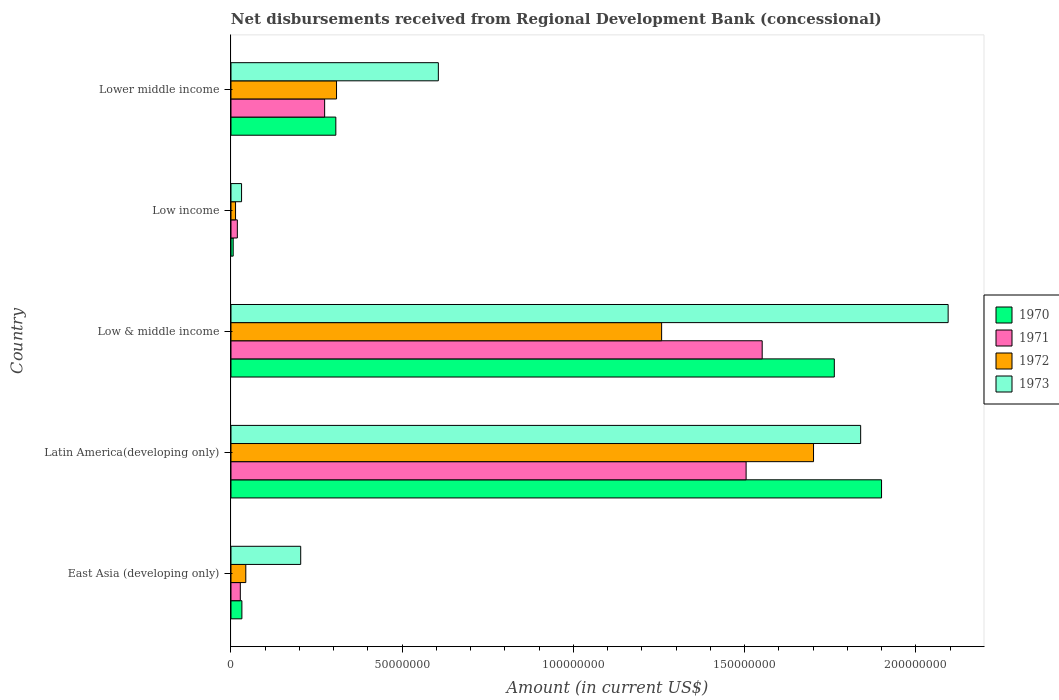How many different coloured bars are there?
Your answer should be compact. 4. How many groups of bars are there?
Offer a terse response. 5. Are the number of bars on each tick of the Y-axis equal?
Ensure brevity in your answer.  Yes. How many bars are there on the 3rd tick from the top?
Offer a terse response. 4. What is the label of the 1st group of bars from the top?
Keep it short and to the point. Lower middle income. In how many cases, is the number of bars for a given country not equal to the number of legend labels?
Your response must be concise. 0. What is the amount of disbursements received from Regional Development Bank in 1970 in Lower middle income?
Provide a short and direct response. 3.06e+07. Across all countries, what is the maximum amount of disbursements received from Regional Development Bank in 1970?
Give a very brief answer. 1.90e+08. Across all countries, what is the minimum amount of disbursements received from Regional Development Bank in 1973?
Keep it short and to the point. 3.09e+06. In which country was the amount of disbursements received from Regional Development Bank in 1971 maximum?
Provide a succinct answer. Low & middle income. In which country was the amount of disbursements received from Regional Development Bank in 1971 minimum?
Offer a terse response. Low income. What is the total amount of disbursements received from Regional Development Bank in 1972 in the graph?
Give a very brief answer. 3.32e+08. What is the difference between the amount of disbursements received from Regional Development Bank in 1971 in Latin America(developing only) and that in Low & middle income?
Provide a short and direct response. -4.69e+06. What is the difference between the amount of disbursements received from Regional Development Bank in 1972 in Latin America(developing only) and the amount of disbursements received from Regional Development Bank in 1973 in Lower middle income?
Provide a short and direct response. 1.10e+08. What is the average amount of disbursements received from Regional Development Bank in 1973 per country?
Your answer should be compact. 9.55e+07. What is the difference between the amount of disbursements received from Regional Development Bank in 1971 and amount of disbursements received from Regional Development Bank in 1973 in Low income?
Make the answer very short. -1.23e+06. What is the ratio of the amount of disbursements received from Regional Development Bank in 1971 in East Asia (developing only) to that in Low & middle income?
Your answer should be very brief. 0.02. What is the difference between the highest and the second highest amount of disbursements received from Regional Development Bank in 1972?
Your response must be concise. 4.44e+07. What is the difference between the highest and the lowest amount of disbursements received from Regional Development Bank in 1970?
Your answer should be compact. 1.89e+08. Is the sum of the amount of disbursements received from Regional Development Bank in 1973 in Latin America(developing only) and Lower middle income greater than the maximum amount of disbursements received from Regional Development Bank in 1970 across all countries?
Offer a terse response. Yes. Is it the case that in every country, the sum of the amount of disbursements received from Regional Development Bank in 1970 and amount of disbursements received from Regional Development Bank in 1971 is greater than the sum of amount of disbursements received from Regional Development Bank in 1973 and amount of disbursements received from Regional Development Bank in 1972?
Keep it short and to the point. No. What does the 1st bar from the top in Low income represents?
Give a very brief answer. 1973. What does the 4th bar from the bottom in Latin America(developing only) represents?
Provide a short and direct response. 1973. Is it the case that in every country, the sum of the amount of disbursements received from Regional Development Bank in 1973 and amount of disbursements received from Regional Development Bank in 1972 is greater than the amount of disbursements received from Regional Development Bank in 1970?
Your answer should be compact. Yes. Are all the bars in the graph horizontal?
Your answer should be very brief. Yes. How many countries are there in the graph?
Your response must be concise. 5. Where does the legend appear in the graph?
Provide a succinct answer. Center right. How are the legend labels stacked?
Offer a very short reply. Vertical. What is the title of the graph?
Offer a terse response. Net disbursements received from Regional Development Bank (concessional). Does "1994" appear as one of the legend labels in the graph?
Offer a very short reply. No. What is the Amount (in current US$) in 1970 in East Asia (developing only)?
Give a very brief answer. 3.19e+06. What is the Amount (in current US$) of 1971 in East Asia (developing only)?
Your answer should be compact. 2.73e+06. What is the Amount (in current US$) in 1972 in East Asia (developing only)?
Your answer should be very brief. 4.33e+06. What is the Amount (in current US$) of 1973 in East Asia (developing only)?
Keep it short and to the point. 2.04e+07. What is the Amount (in current US$) in 1970 in Latin America(developing only)?
Offer a very short reply. 1.90e+08. What is the Amount (in current US$) of 1971 in Latin America(developing only)?
Your answer should be compact. 1.50e+08. What is the Amount (in current US$) in 1972 in Latin America(developing only)?
Provide a succinct answer. 1.70e+08. What is the Amount (in current US$) in 1973 in Latin America(developing only)?
Offer a very short reply. 1.84e+08. What is the Amount (in current US$) in 1970 in Low & middle income?
Provide a succinct answer. 1.76e+08. What is the Amount (in current US$) of 1971 in Low & middle income?
Offer a very short reply. 1.55e+08. What is the Amount (in current US$) in 1972 in Low & middle income?
Give a very brief answer. 1.26e+08. What is the Amount (in current US$) of 1973 in Low & middle income?
Provide a short and direct response. 2.09e+08. What is the Amount (in current US$) of 1970 in Low income?
Provide a short and direct response. 6.47e+05. What is the Amount (in current US$) in 1971 in Low income?
Offer a terse response. 1.86e+06. What is the Amount (in current US$) of 1972 in Low income?
Make the answer very short. 1.33e+06. What is the Amount (in current US$) in 1973 in Low income?
Offer a very short reply. 3.09e+06. What is the Amount (in current US$) of 1970 in Lower middle income?
Ensure brevity in your answer.  3.06e+07. What is the Amount (in current US$) of 1971 in Lower middle income?
Keep it short and to the point. 2.74e+07. What is the Amount (in current US$) of 1972 in Lower middle income?
Make the answer very short. 3.08e+07. What is the Amount (in current US$) of 1973 in Lower middle income?
Keep it short and to the point. 6.06e+07. Across all countries, what is the maximum Amount (in current US$) in 1970?
Offer a very short reply. 1.90e+08. Across all countries, what is the maximum Amount (in current US$) of 1971?
Provide a succinct answer. 1.55e+08. Across all countries, what is the maximum Amount (in current US$) in 1972?
Make the answer very short. 1.70e+08. Across all countries, what is the maximum Amount (in current US$) of 1973?
Offer a very short reply. 2.09e+08. Across all countries, what is the minimum Amount (in current US$) in 1970?
Offer a very short reply. 6.47e+05. Across all countries, what is the minimum Amount (in current US$) of 1971?
Your answer should be very brief. 1.86e+06. Across all countries, what is the minimum Amount (in current US$) of 1972?
Offer a very short reply. 1.33e+06. Across all countries, what is the minimum Amount (in current US$) in 1973?
Give a very brief answer. 3.09e+06. What is the total Amount (in current US$) of 1970 in the graph?
Your answer should be compact. 4.01e+08. What is the total Amount (in current US$) in 1971 in the graph?
Provide a succinct answer. 3.38e+08. What is the total Amount (in current US$) of 1972 in the graph?
Keep it short and to the point. 3.32e+08. What is the total Amount (in current US$) of 1973 in the graph?
Offer a very short reply. 4.77e+08. What is the difference between the Amount (in current US$) in 1970 in East Asia (developing only) and that in Latin America(developing only)?
Provide a succinct answer. -1.87e+08. What is the difference between the Amount (in current US$) of 1971 in East Asia (developing only) and that in Latin America(developing only)?
Your response must be concise. -1.48e+08. What is the difference between the Amount (in current US$) in 1972 in East Asia (developing only) and that in Latin America(developing only)?
Your response must be concise. -1.66e+08. What is the difference between the Amount (in current US$) of 1973 in East Asia (developing only) and that in Latin America(developing only)?
Give a very brief answer. -1.64e+08. What is the difference between the Amount (in current US$) of 1970 in East Asia (developing only) and that in Low & middle income?
Give a very brief answer. -1.73e+08. What is the difference between the Amount (in current US$) in 1971 in East Asia (developing only) and that in Low & middle income?
Offer a very short reply. -1.52e+08. What is the difference between the Amount (in current US$) of 1972 in East Asia (developing only) and that in Low & middle income?
Make the answer very short. -1.21e+08. What is the difference between the Amount (in current US$) in 1973 in East Asia (developing only) and that in Low & middle income?
Provide a succinct answer. -1.89e+08. What is the difference between the Amount (in current US$) in 1970 in East Asia (developing only) and that in Low income?
Offer a terse response. 2.54e+06. What is the difference between the Amount (in current US$) of 1971 in East Asia (developing only) and that in Low income?
Your answer should be very brief. 8.69e+05. What is the difference between the Amount (in current US$) in 1972 in East Asia (developing only) and that in Low income?
Keep it short and to the point. 2.99e+06. What is the difference between the Amount (in current US$) in 1973 in East Asia (developing only) and that in Low income?
Offer a terse response. 1.73e+07. What is the difference between the Amount (in current US$) in 1970 in East Asia (developing only) and that in Lower middle income?
Offer a terse response. -2.74e+07. What is the difference between the Amount (in current US$) of 1971 in East Asia (developing only) and that in Lower middle income?
Ensure brevity in your answer.  -2.46e+07. What is the difference between the Amount (in current US$) in 1972 in East Asia (developing only) and that in Lower middle income?
Your response must be concise. -2.65e+07. What is the difference between the Amount (in current US$) of 1973 in East Asia (developing only) and that in Lower middle income?
Ensure brevity in your answer.  -4.02e+07. What is the difference between the Amount (in current US$) in 1970 in Latin America(developing only) and that in Low & middle income?
Offer a very short reply. 1.38e+07. What is the difference between the Amount (in current US$) in 1971 in Latin America(developing only) and that in Low & middle income?
Keep it short and to the point. -4.69e+06. What is the difference between the Amount (in current US$) in 1972 in Latin America(developing only) and that in Low & middle income?
Your answer should be very brief. 4.44e+07. What is the difference between the Amount (in current US$) in 1973 in Latin America(developing only) and that in Low & middle income?
Keep it short and to the point. -2.55e+07. What is the difference between the Amount (in current US$) of 1970 in Latin America(developing only) and that in Low income?
Ensure brevity in your answer.  1.89e+08. What is the difference between the Amount (in current US$) in 1971 in Latin America(developing only) and that in Low income?
Make the answer very short. 1.49e+08. What is the difference between the Amount (in current US$) in 1972 in Latin America(developing only) and that in Low income?
Your response must be concise. 1.69e+08. What is the difference between the Amount (in current US$) in 1973 in Latin America(developing only) and that in Low income?
Your answer should be compact. 1.81e+08. What is the difference between the Amount (in current US$) of 1970 in Latin America(developing only) and that in Lower middle income?
Your response must be concise. 1.59e+08. What is the difference between the Amount (in current US$) in 1971 in Latin America(developing only) and that in Lower middle income?
Ensure brevity in your answer.  1.23e+08. What is the difference between the Amount (in current US$) of 1972 in Latin America(developing only) and that in Lower middle income?
Keep it short and to the point. 1.39e+08. What is the difference between the Amount (in current US$) of 1973 in Latin America(developing only) and that in Lower middle income?
Your answer should be compact. 1.23e+08. What is the difference between the Amount (in current US$) in 1970 in Low & middle income and that in Low income?
Give a very brief answer. 1.76e+08. What is the difference between the Amount (in current US$) in 1971 in Low & middle income and that in Low income?
Offer a terse response. 1.53e+08. What is the difference between the Amount (in current US$) of 1972 in Low & middle income and that in Low income?
Ensure brevity in your answer.  1.24e+08. What is the difference between the Amount (in current US$) of 1973 in Low & middle income and that in Low income?
Offer a terse response. 2.06e+08. What is the difference between the Amount (in current US$) of 1970 in Low & middle income and that in Lower middle income?
Give a very brief answer. 1.46e+08. What is the difference between the Amount (in current US$) in 1971 in Low & middle income and that in Lower middle income?
Give a very brief answer. 1.28e+08. What is the difference between the Amount (in current US$) of 1972 in Low & middle income and that in Lower middle income?
Provide a succinct answer. 9.49e+07. What is the difference between the Amount (in current US$) of 1973 in Low & middle income and that in Lower middle income?
Offer a very short reply. 1.49e+08. What is the difference between the Amount (in current US$) of 1970 in Low income and that in Lower middle income?
Provide a short and direct response. -3.00e+07. What is the difference between the Amount (in current US$) of 1971 in Low income and that in Lower middle income?
Give a very brief answer. -2.55e+07. What is the difference between the Amount (in current US$) in 1972 in Low income and that in Lower middle income?
Keep it short and to the point. -2.95e+07. What is the difference between the Amount (in current US$) in 1973 in Low income and that in Lower middle income?
Give a very brief answer. -5.75e+07. What is the difference between the Amount (in current US$) in 1970 in East Asia (developing only) and the Amount (in current US$) in 1971 in Latin America(developing only)?
Ensure brevity in your answer.  -1.47e+08. What is the difference between the Amount (in current US$) in 1970 in East Asia (developing only) and the Amount (in current US$) in 1972 in Latin America(developing only)?
Your response must be concise. -1.67e+08. What is the difference between the Amount (in current US$) of 1970 in East Asia (developing only) and the Amount (in current US$) of 1973 in Latin America(developing only)?
Make the answer very short. -1.81e+08. What is the difference between the Amount (in current US$) in 1971 in East Asia (developing only) and the Amount (in current US$) in 1972 in Latin America(developing only)?
Offer a terse response. -1.67e+08. What is the difference between the Amount (in current US$) of 1971 in East Asia (developing only) and the Amount (in current US$) of 1973 in Latin America(developing only)?
Keep it short and to the point. -1.81e+08. What is the difference between the Amount (in current US$) of 1972 in East Asia (developing only) and the Amount (in current US$) of 1973 in Latin America(developing only)?
Make the answer very short. -1.80e+08. What is the difference between the Amount (in current US$) of 1970 in East Asia (developing only) and the Amount (in current US$) of 1971 in Low & middle income?
Ensure brevity in your answer.  -1.52e+08. What is the difference between the Amount (in current US$) in 1970 in East Asia (developing only) and the Amount (in current US$) in 1972 in Low & middle income?
Offer a very short reply. -1.23e+08. What is the difference between the Amount (in current US$) in 1970 in East Asia (developing only) and the Amount (in current US$) in 1973 in Low & middle income?
Keep it short and to the point. -2.06e+08. What is the difference between the Amount (in current US$) in 1971 in East Asia (developing only) and the Amount (in current US$) in 1972 in Low & middle income?
Keep it short and to the point. -1.23e+08. What is the difference between the Amount (in current US$) in 1971 in East Asia (developing only) and the Amount (in current US$) in 1973 in Low & middle income?
Provide a succinct answer. -2.07e+08. What is the difference between the Amount (in current US$) of 1972 in East Asia (developing only) and the Amount (in current US$) of 1973 in Low & middle income?
Your response must be concise. -2.05e+08. What is the difference between the Amount (in current US$) of 1970 in East Asia (developing only) and the Amount (in current US$) of 1971 in Low income?
Make the answer very short. 1.33e+06. What is the difference between the Amount (in current US$) of 1970 in East Asia (developing only) and the Amount (in current US$) of 1972 in Low income?
Provide a short and direct response. 1.86e+06. What is the difference between the Amount (in current US$) in 1970 in East Asia (developing only) and the Amount (in current US$) in 1973 in Low income?
Provide a succinct answer. 9.80e+04. What is the difference between the Amount (in current US$) in 1971 in East Asia (developing only) and the Amount (in current US$) in 1972 in Low income?
Make the answer very short. 1.40e+06. What is the difference between the Amount (in current US$) of 1971 in East Asia (developing only) and the Amount (in current US$) of 1973 in Low income?
Provide a short and direct response. -3.63e+05. What is the difference between the Amount (in current US$) of 1972 in East Asia (developing only) and the Amount (in current US$) of 1973 in Low income?
Make the answer very short. 1.24e+06. What is the difference between the Amount (in current US$) in 1970 in East Asia (developing only) and the Amount (in current US$) in 1971 in Lower middle income?
Your response must be concise. -2.42e+07. What is the difference between the Amount (in current US$) in 1970 in East Asia (developing only) and the Amount (in current US$) in 1972 in Lower middle income?
Provide a succinct answer. -2.76e+07. What is the difference between the Amount (in current US$) of 1970 in East Asia (developing only) and the Amount (in current US$) of 1973 in Lower middle income?
Your answer should be compact. -5.74e+07. What is the difference between the Amount (in current US$) in 1971 in East Asia (developing only) and the Amount (in current US$) in 1972 in Lower middle income?
Keep it short and to the point. -2.81e+07. What is the difference between the Amount (in current US$) in 1971 in East Asia (developing only) and the Amount (in current US$) in 1973 in Lower middle income?
Provide a short and direct response. -5.78e+07. What is the difference between the Amount (in current US$) of 1972 in East Asia (developing only) and the Amount (in current US$) of 1973 in Lower middle income?
Offer a terse response. -5.62e+07. What is the difference between the Amount (in current US$) in 1970 in Latin America(developing only) and the Amount (in current US$) in 1971 in Low & middle income?
Offer a terse response. 3.49e+07. What is the difference between the Amount (in current US$) of 1970 in Latin America(developing only) and the Amount (in current US$) of 1972 in Low & middle income?
Ensure brevity in your answer.  6.42e+07. What is the difference between the Amount (in current US$) in 1970 in Latin America(developing only) and the Amount (in current US$) in 1973 in Low & middle income?
Ensure brevity in your answer.  -1.94e+07. What is the difference between the Amount (in current US$) in 1971 in Latin America(developing only) and the Amount (in current US$) in 1972 in Low & middle income?
Provide a succinct answer. 2.47e+07. What is the difference between the Amount (in current US$) of 1971 in Latin America(developing only) and the Amount (in current US$) of 1973 in Low & middle income?
Offer a very short reply. -5.90e+07. What is the difference between the Amount (in current US$) of 1972 in Latin America(developing only) and the Amount (in current US$) of 1973 in Low & middle income?
Provide a succinct answer. -3.93e+07. What is the difference between the Amount (in current US$) in 1970 in Latin America(developing only) and the Amount (in current US$) in 1971 in Low income?
Provide a short and direct response. 1.88e+08. What is the difference between the Amount (in current US$) of 1970 in Latin America(developing only) and the Amount (in current US$) of 1972 in Low income?
Your answer should be very brief. 1.89e+08. What is the difference between the Amount (in current US$) of 1970 in Latin America(developing only) and the Amount (in current US$) of 1973 in Low income?
Make the answer very short. 1.87e+08. What is the difference between the Amount (in current US$) of 1971 in Latin America(developing only) and the Amount (in current US$) of 1972 in Low income?
Offer a terse response. 1.49e+08. What is the difference between the Amount (in current US$) in 1971 in Latin America(developing only) and the Amount (in current US$) in 1973 in Low income?
Ensure brevity in your answer.  1.47e+08. What is the difference between the Amount (in current US$) in 1972 in Latin America(developing only) and the Amount (in current US$) in 1973 in Low income?
Your answer should be very brief. 1.67e+08. What is the difference between the Amount (in current US$) in 1970 in Latin America(developing only) and the Amount (in current US$) in 1971 in Lower middle income?
Provide a succinct answer. 1.63e+08. What is the difference between the Amount (in current US$) in 1970 in Latin America(developing only) and the Amount (in current US$) in 1972 in Lower middle income?
Keep it short and to the point. 1.59e+08. What is the difference between the Amount (in current US$) in 1970 in Latin America(developing only) and the Amount (in current US$) in 1973 in Lower middle income?
Provide a short and direct response. 1.29e+08. What is the difference between the Amount (in current US$) of 1971 in Latin America(developing only) and the Amount (in current US$) of 1972 in Lower middle income?
Make the answer very short. 1.20e+08. What is the difference between the Amount (in current US$) of 1971 in Latin America(developing only) and the Amount (in current US$) of 1973 in Lower middle income?
Offer a terse response. 8.99e+07. What is the difference between the Amount (in current US$) in 1972 in Latin America(developing only) and the Amount (in current US$) in 1973 in Lower middle income?
Offer a terse response. 1.10e+08. What is the difference between the Amount (in current US$) in 1970 in Low & middle income and the Amount (in current US$) in 1971 in Low income?
Your answer should be compact. 1.74e+08. What is the difference between the Amount (in current US$) in 1970 in Low & middle income and the Amount (in current US$) in 1972 in Low income?
Your response must be concise. 1.75e+08. What is the difference between the Amount (in current US$) in 1970 in Low & middle income and the Amount (in current US$) in 1973 in Low income?
Keep it short and to the point. 1.73e+08. What is the difference between the Amount (in current US$) of 1971 in Low & middle income and the Amount (in current US$) of 1972 in Low income?
Provide a short and direct response. 1.54e+08. What is the difference between the Amount (in current US$) in 1971 in Low & middle income and the Amount (in current US$) in 1973 in Low income?
Make the answer very short. 1.52e+08. What is the difference between the Amount (in current US$) in 1972 in Low & middle income and the Amount (in current US$) in 1973 in Low income?
Keep it short and to the point. 1.23e+08. What is the difference between the Amount (in current US$) of 1970 in Low & middle income and the Amount (in current US$) of 1971 in Lower middle income?
Provide a succinct answer. 1.49e+08. What is the difference between the Amount (in current US$) of 1970 in Low & middle income and the Amount (in current US$) of 1972 in Lower middle income?
Provide a short and direct response. 1.45e+08. What is the difference between the Amount (in current US$) in 1970 in Low & middle income and the Amount (in current US$) in 1973 in Lower middle income?
Provide a succinct answer. 1.16e+08. What is the difference between the Amount (in current US$) of 1971 in Low & middle income and the Amount (in current US$) of 1972 in Lower middle income?
Offer a terse response. 1.24e+08. What is the difference between the Amount (in current US$) in 1971 in Low & middle income and the Amount (in current US$) in 1973 in Lower middle income?
Make the answer very short. 9.46e+07. What is the difference between the Amount (in current US$) of 1972 in Low & middle income and the Amount (in current US$) of 1973 in Lower middle income?
Provide a short and direct response. 6.52e+07. What is the difference between the Amount (in current US$) of 1970 in Low income and the Amount (in current US$) of 1971 in Lower middle income?
Make the answer very short. -2.67e+07. What is the difference between the Amount (in current US$) in 1970 in Low income and the Amount (in current US$) in 1972 in Lower middle income?
Keep it short and to the point. -3.02e+07. What is the difference between the Amount (in current US$) in 1970 in Low income and the Amount (in current US$) in 1973 in Lower middle income?
Your answer should be very brief. -5.99e+07. What is the difference between the Amount (in current US$) of 1971 in Low income and the Amount (in current US$) of 1972 in Lower middle income?
Provide a short and direct response. -2.90e+07. What is the difference between the Amount (in current US$) of 1971 in Low income and the Amount (in current US$) of 1973 in Lower middle income?
Offer a terse response. -5.87e+07. What is the difference between the Amount (in current US$) of 1972 in Low income and the Amount (in current US$) of 1973 in Lower middle income?
Provide a succinct answer. -5.92e+07. What is the average Amount (in current US$) in 1970 per country?
Your answer should be compact. 8.01e+07. What is the average Amount (in current US$) of 1971 per country?
Offer a terse response. 6.75e+07. What is the average Amount (in current US$) in 1972 per country?
Offer a very short reply. 6.65e+07. What is the average Amount (in current US$) of 1973 per country?
Make the answer very short. 9.55e+07. What is the difference between the Amount (in current US$) in 1970 and Amount (in current US$) in 1971 in East Asia (developing only)?
Offer a very short reply. 4.61e+05. What is the difference between the Amount (in current US$) of 1970 and Amount (in current US$) of 1972 in East Asia (developing only)?
Provide a succinct answer. -1.14e+06. What is the difference between the Amount (in current US$) in 1970 and Amount (in current US$) in 1973 in East Asia (developing only)?
Your answer should be compact. -1.72e+07. What is the difference between the Amount (in current US$) in 1971 and Amount (in current US$) in 1972 in East Asia (developing only)?
Offer a very short reply. -1.60e+06. What is the difference between the Amount (in current US$) in 1971 and Amount (in current US$) in 1973 in East Asia (developing only)?
Your answer should be compact. -1.76e+07. What is the difference between the Amount (in current US$) of 1972 and Amount (in current US$) of 1973 in East Asia (developing only)?
Ensure brevity in your answer.  -1.60e+07. What is the difference between the Amount (in current US$) of 1970 and Amount (in current US$) of 1971 in Latin America(developing only)?
Keep it short and to the point. 3.96e+07. What is the difference between the Amount (in current US$) of 1970 and Amount (in current US$) of 1972 in Latin America(developing only)?
Offer a terse response. 1.99e+07. What is the difference between the Amount (in current US$) in 1970 and Amount (in current US$) in 1973 in Latin America(developing only)?
Keep it short and to the point. 6.10e+06. What is the difference between the Amount (in current US$) of 1971 and Amount (in current US$) of 1972 in Latin America(developing only)?
Provide a short and direct response. -1.97e+07. What is the difference between the Amount (in current US$) in 1971 and Amount (in current US$) in 1973 in Latin America(developing only)?
Provide a short and direct response. -3.35e+07. What is the difference between the Amount (in current US$) of 1972 and Amount (in current US$) of 1973 in Latin America(developing only)?
Provide a short and direct response. -1.38e+07. What is the difference between the Amount (in current US$) of 1970 and Amount (in current US$) of 1971 in Low & middle income?
Ensure brevity in your answer.  2.11e+07. What is the difference between the Amount (in current US$) of 1970 and Amount (in current US$) of 1972 in Low & middle income?
Your answer should be compact. 5.04e+07. What is the difference between the Amount (in current US$) in 1970 and Amount (in current US$) in 1973 in Low & middle income?
Provide a succinct answer. -3.32e+07. What is the difference between the Amount (in current US$) of 1971 and Amount (in current US$) of 1972 in Low & middle income?
Make the answer very short. 2.94e+07. What is the difference between the Amount (in current US$) of 1971 and Amount (in current US$) of 1973 in Low & middle income?
Keep it short and to the point. -5.43e+07. What is the difference between the Amount (in current US$) in 1972 and Amount (in current US$) in 1973 in Low & middle income?
Your response must be concise. -8.37e+07. What is the difference between the Amount (in current US$) in 1970 and Amount (in current US$) in 1971 in Low income?
Offer a terse response. -1.21e+06. What is the difference between the Amount (in current US$) of 1970 and Amount (in current US$) of 1972 in Low income?
Provide a succinct answer. -6.86e+05. What is the difference between the Amount (in current US$) in 1970 and Amount (in current US$) in 1973 in Low income?
Offer a very short reply. -2.44e+06. What is the difference between the Amount (in current US$) in 1971 and Amount (in current US$) in 1972 in Low income?
Give a very brief answer. 5.26e+05. What is the difference between the Amount (in current US$) in 1971 and Amount (in current US$) in 1973 in Low income?
Your answer should be very brief. -1.23e+06. What is the difference between the Amount (in current US$) in 1972 and Amount (in current US$) in 1973 in Low income?
Your answer should be very brief. -1.76e+06. What is the difference between the Amount (in current US$) of 1970 and Amount (in current US$) of 1971 in Lower middle income?
Your answer should be very brief. 3.27e+06. What is the difference between the Amount (in current US$) of 1970 and Amount (in current US$) of 1972 in Lower middle income?
Offer a very short reply. -2.02e+05. What is the difference between the Amount (in current US$) of 1970 and Amount (in current US$) of 1973 in Lower middle income?
Your answer should be compact. -2.99e+07. What is the difference between the Amount (in current US$) of 1971 and Amount (in current US$) of 1972 in Lower middle income?
Keep it short and to the point. -3.47e+06. What is the difference between the Amount (in current US$) of 1971 and Amount (in current US$) of 1973 in Lower middle income?
Your response must be concise. -3.32e+07. What is the difference between the Amount (in current US$) of 1972 and Amount (in current US$) of 1973 in Lower middle income?
Offer a very short reply. -2.97e+07. What is the ratio of the Amount (in current US$) in 1970 in East Asia (developing only) to that in Latin America(developing only)?
Make the answer very short. 0.02. What is the ratio of the Amount (in current US$) in 1971 in East Asia (developing only) to that in Latin America(developing only)?
Your answer should be very brief. 0.02. What is the ratio of the Amount (in current US$) of 1972 in East Asia (developing only) to that in Latin America(developing only)?
Keep it short and to the point. 0.03. What is the ratio of the Amount (in current US$) of 1973 in East Asia (developing only) to that in Latin America(developing only)?
Your answer should be compact. 0.11. What is the ratio of the Amount (in current US$) of 1970 in East Asia (developing only) to that in Low & middle income?
Provide a short and direct response. 0.02. What is the ratio of the Amount (in current US$) in 1971 in East Asia (developing only) to that in Low & middle income?
Keep it short and to the point. 0.02. What is the ratio of the Amount (in current US$) in 1972 in East Asia (developing only) to that in Low & middle income?
Offer a very short reply. 0.03. What is the ratio of the Amount (in current US$) of 1973 in East Asia (developing only) to that in Low & middle income?
Make the answer very short. 0.1. What is the ratio of the Amount (in current US$) of 1970 in East Asia (developing only) to that in Low income?
Give a very brief answer. 4.93. What is the ratio of the Amount (in current US$) of 1971 in East Asia (developing only) to that in Low income?
Make the answer very short. 1.47. What is the ratio of the Amount (in current US$) of 1972 in East Asia (developing only) to that in Low income?
Ensure brevity in your answer.  3.25. What is the ratio of the Amount (in current US$) in 1973 in East Asia (developing only) to that in Low income?
Your response must be concise. 6.59. What is the ratio of the Amount (in current US$) in 1970 in East Asia (developing only) to that in Lower middle income?
Provide a succinct answer. 0.1. What is the ratio of the Amount (in current US$) in 1971 in East Asia (developing only) to that in Lower middle income?
Make the answer very short. 0.1. What is the ratio of the Amount (in current US$) of 1972 in East Asia (developing only) to that in Lower middle income?
Make the answer very short. 0.14. What is the ratio of the Amount (in current US$) in 1973 in East Asia (developing only) to that in Lower middle income?
Provide a short and direct response. 0.34. What is the ratio of the Amount (in current US$) in 1970 in Latin America(developing only) to that in Low & middle income?
Offer a terse response. 1.08. What is the ratio of the Amount (in current US$) of 1971 in Latin America(developing only) to that in Low & middle income?
Make the answer very short. 0.97. What is the ratio of the Amount (in current US$) in 1972 in Latin America(developing only) to that in Low & middle income?
Give a very brief answer. 1.35. What is the ratio of the Amount (in current US$) in 1973 in Latin America(developing only) to that in Low & middle income?
Keep it short and to the point. 0.88. What is the ratio of the Amount (in current US$) of 1970 in Latin America(developing only) to that in Low income?
Your answer should be compact. 293.65. What is the ratio of the Amount (in current US$) of 1971 in Latin America(developing only) to that in Low income?
Give a very brief answer. 80.93. What is the ratio of the Amount (in current US$) in 1972 in Latin America(developing only) to that in Low income?
Make the answer very short. 127.63. What is the ratio of the Amount (in current US$) of 1973 in Latin America(developing only) to that in Low income?
Your response must be concise. 59.49. What is the ratio of the Amount (in current US$) of 1970 in Latin America(developing only) to that in Lower middle income?
Provide a succinct answer. 6.2. What is the ratio of the Amount (in current US$) in 1971 in Latin America(developing only) to that in Lower middle income?
Offer a very short reply. 5.5. What is the ratio of the Amount (in current US$) in 1972 in Latin America(developing only) to that in Lower middle income?
Give a very brief answer. 5.52. What is the ratio of the Amount (in current US$) in 1973 in Latin America(developing only) to that in Lower middle income?
Make the answer very short. 3.04. What is the ratio of the Amount (in current US$) of 1970 in Low & middle income to that in Low income?
Your response must be concise. 272.33. What is the ratio of the Amount (in current US$) of 1971 in Low & middle income to that in Low income?
Your answer should be very brief. 83.45. What is the ratio of the Amount (in current US$) of 1972 in Low & middle income to that in Low income?
Offer a very short reply. 94.35. What is the ratio of the Amount (in current US$) of 1973 in Low & middle income to that in Low income?
Give a very brief answer. 67.76. What is the ratio of the Amount (in current US$) of 1970 in Low & middle income to that in Lower middle income?
Keep it short and to the point. 5.75. What is the ratio of the Amount (in current US$) in 1971 in Low & middle income to that in Lower middle income?
Ensure brevity in your answer.  5.67. What is the ratio of the Amount (in current US$) in 1972 in Low & middle income to that in Lower middle income?
Give a very brief answer. 4.08. What is the ratio of the Amount (in current US$) of 1973 in Low & middle income to that in Lower middle income?
Give a very brief answer. 3.46. What is the ratio of the Amount (in current US$) in 1970 in Low income to that in Lower middle income?
Offer a terse response. 0.02. What is the ratio of the Amount (in current US$) of 1971 in Low income to that in Lower middle income?
Offer a terse response. 0.07. What is the ratio of the Amount (in current US$) in 1972 in Low income to that in Lower middle income?
Keep it short and to the point. 0.04. What is the ratio of the Amount (in current US$) of 1973 in Low income to that in Lower middle income?
Your response must be concise. 0.05. What is the difference between the highest and the second highest Amount (in current US$) of 1970?
Your answer should be compact. 1.38e+07. What is the difference between the highest and the second highest Amount (in current US$) in 1971?
Ensure brevity in your answer.  4.69e+06. What is the difference between the highest and the second highest Amount (in current US$) of 1972?
Ensure brevity in your answer.  4.44e+07. What is the difference between the highest and the second highest Amount (in current US$) in 1973?
Give a very brief answer. 2.55e+07. What is the difference between the highest and the lowest Amount (in current US$) of 1970?
Your response must be concise. 1.89e+08. What is the difference between the highest and the lowest Amount (in current US$) of 1971?
Your response must be concise. 1.53e+08. What is the difference between the highest and the lowest Amount (in current US$) in 1972?
Your answer should be very brief. 1.69e+08. What is the difference between the highest and the lowest Amount (in current US$) of 1973?
Offer a very short reply. 2.06e+08. 